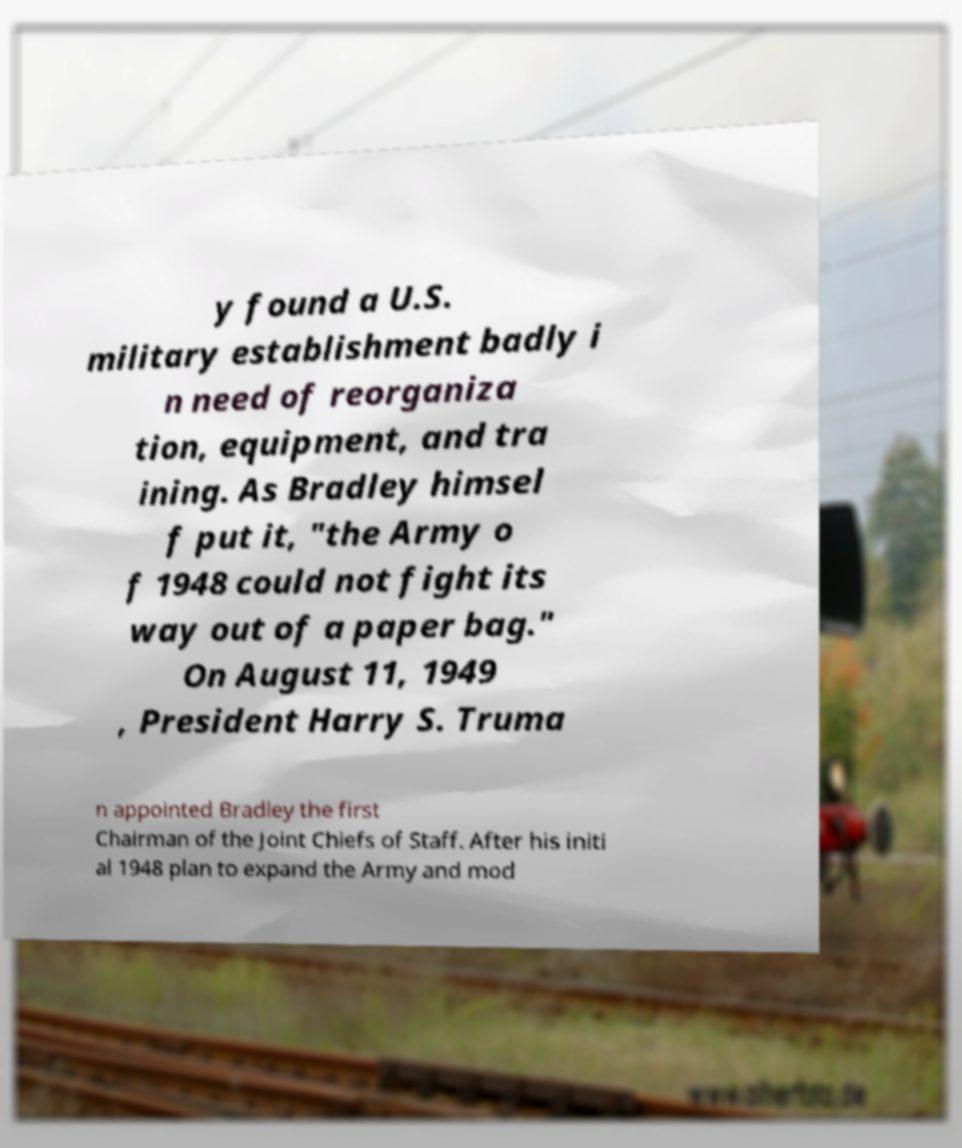Please identify and transcribe the text found in this image. y found a U.S. military establishment badly i n need of reorganiza tion, equipment, and tra ining. As Bradley himsel f put it, "the Army o f 1948 could not fight its way out of a paper bag." On August 11, 1949 , President Harry S. Truma n appointed Bradley the first Chairman of the Joint Chiefs of Staff. After his initi al 1948 plan to expand the Army and mod 